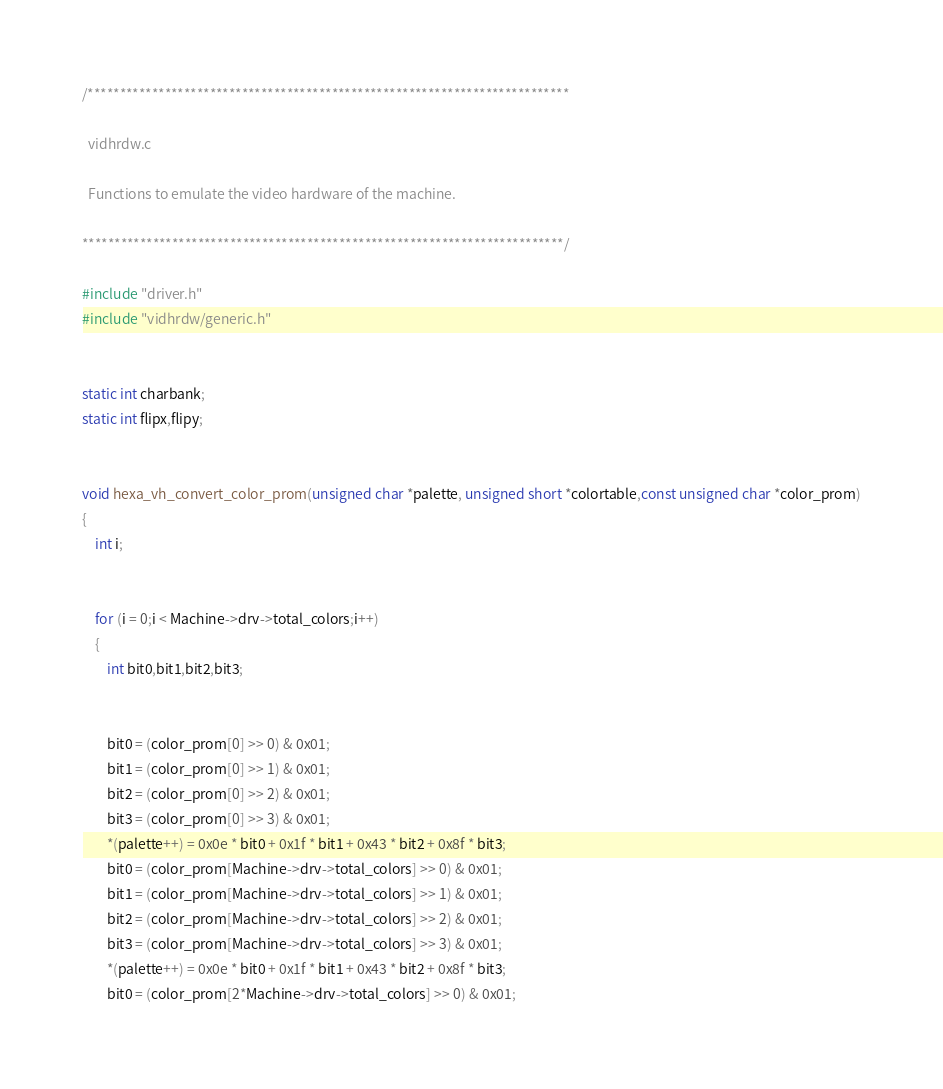<code> <loc_0><loc_0><loc_500><loc_500><_C++_>/***************************************************************************

  vidhrdw.c

  Functions to emulate the video hardware of the machine.

***************************************************************************/

#include "driver.h"
#include "vidhrdw/generic.h"


static int charbank;
static int flipx,flipy;


void hexa_vh_convert_color_prom(unsigned char *palette, unsigned short *colortable,const unsigned char *color_prom)
{
	int i;


	for (i = 0;i < Machine->drv->total_colors;i++)
	{
		int bit0,bit1,bit2,bit3;


		bit0 = (color_prom[0] >> 0) & 0x01;
		bit1 = (color_prom[0] >> 1) & 0x01;
		bit2 = (color_prom[0] >> 2) & 0x01;
		bit3 = (color_prom[0] >> 3) & 0x01;
		*(palette++) = 0x0e * bit0 + 0x1f * bit1 + 0x43 * bit2 + 0x8f * bit3;
		bit0 = (color_prom[Machine->drv->total_colors] >> 0) & 0x01;
		bit1 = (color_prom[Machine->drv->total_colors] >> 1) & 0x01;
		bit2 = (color_prom[Machine->drv->total_colors] >> 2) & 0x01;
		bit3 = (color_prom[Machine->drv->total_colors] >> 3) & 0x01;
		*(palette++) = 0x0e * bit0 + 0x1f * bit1 + 0x43 * bit2 + 0x8f * bit3;
		bit0 = (color_prom[2*Machine->drv->total_colors] >> 0) & 0x01;</code> 